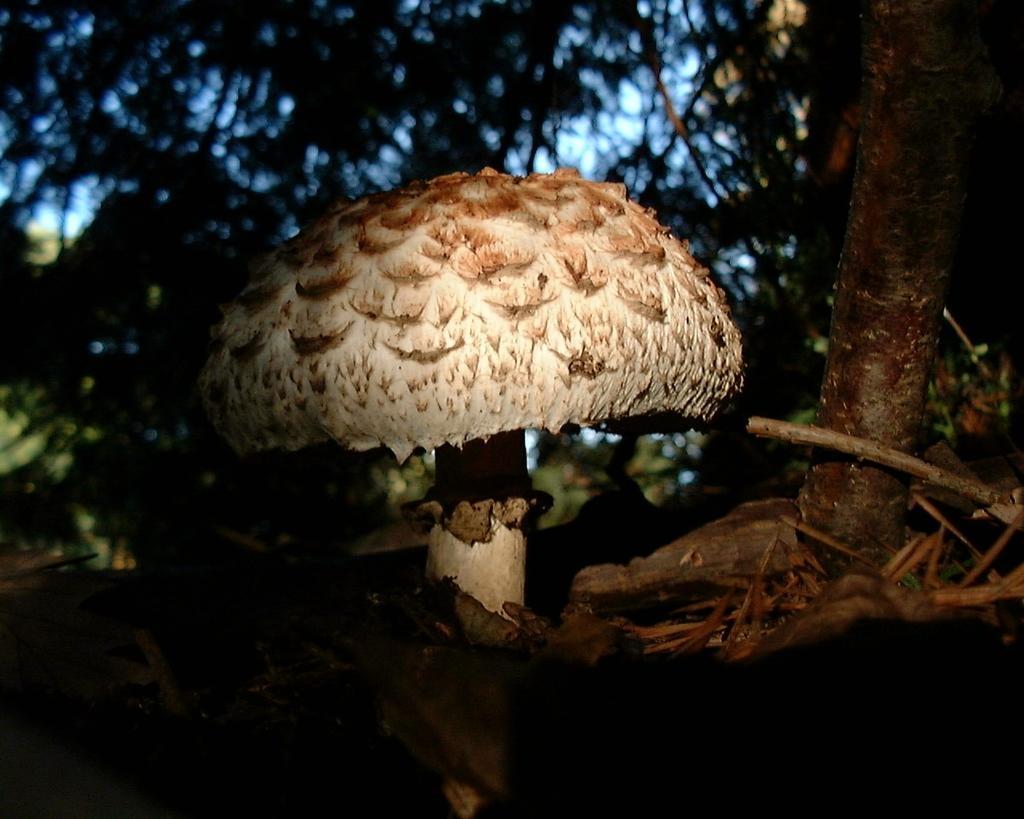Can you describe this image briefly? The picture is taken in a forest. In the foreground of the picture there is a mushroom. In the foreground there are twigs. The background is blurred. In the background there are trees. Sky is visible. 